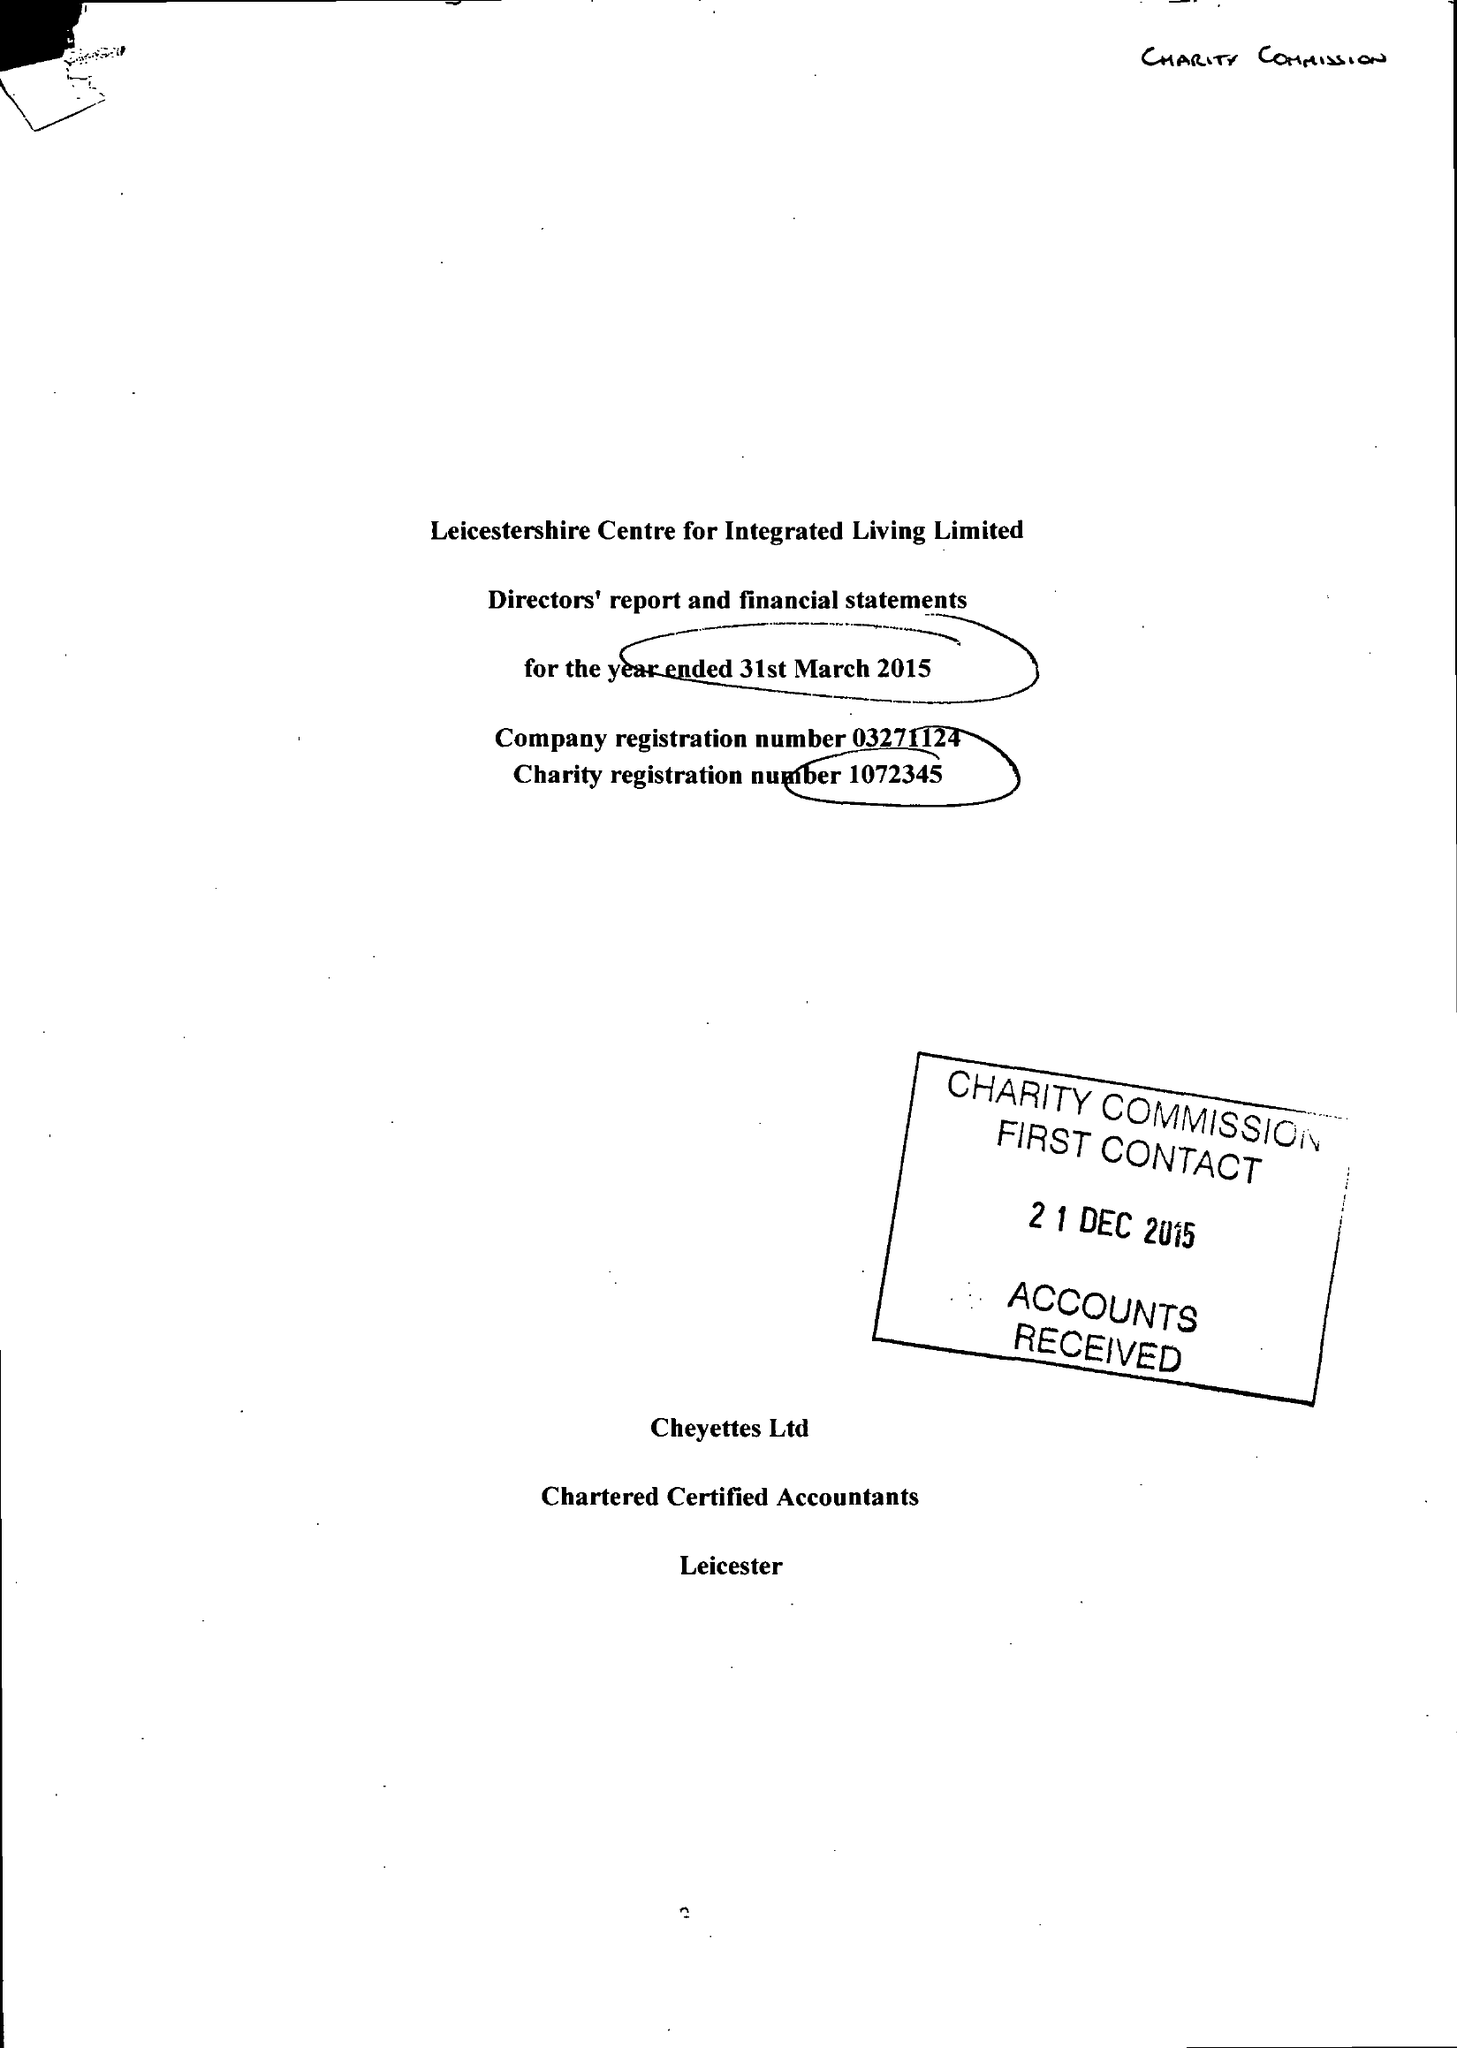What is the value for the charity_name?
Answer the question using a single word or phrase. Leicestershire Centre For Integrated Living Ltd. 